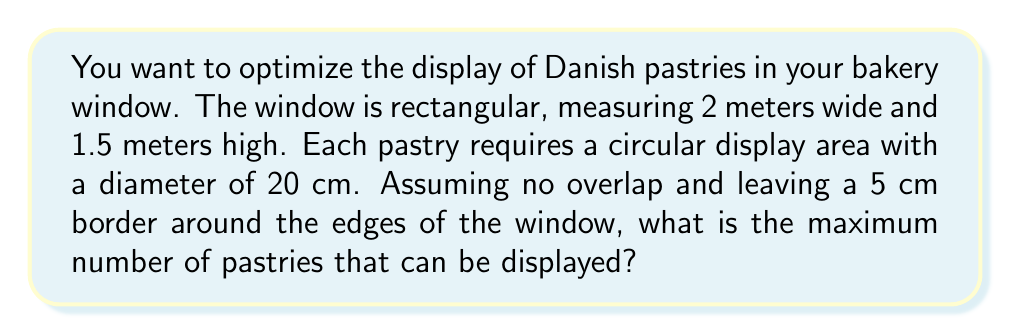Help me with this question. Let's approach this step-by-step:

1) First, calculate the usable area of the window:
   - Width: $2 \text{ m} - (2 \times 0.05 \text{ m}) = 1.9 \text{ m} = 190 \text{ cm}$
   - Height: $1.5 \text{ m} - (2 \times 0.05 \text{ m}) = 1.4 \text{ m} = 140 \text{ cm}$

2) The area needed for each pastry is a circle with diameter 20 cm:
   - Radius = $10 \text{ cm}$
   - Area per pastry = $\pi r^2 = \pi (10 \text{ cm})^2 = 100\pi \text{ cm}^2$

3) To maximize the number of pastries, we need to consider the most efficient packing of circles. The best packing density for circles is achieved with a hexagonal arrangement, which has a packing density of:

   $$\frac{\pi}{2\sqrt{3}} \approx 0.9069$$

4) Calculate the total usable area:
   $190 \text{ cm} \times 140 \text{ cm} = 26,600 \text{ cm}^2$

5) The theoretical maximum number of pastries (n) can be calculated as:

   $$n = \frac{\text{Total Area} \times \text{Packing Density}}{\text{Area per Pastry}}$$

   $$n = \frac{26,600 \text{ cm}^2 \times 0.9069}{100\pi \text{ cm}^2} \approx 76.77$$

6) Since we can't display partial pastries, we round down to the nearest whole number.

Therefore, the maximum number of pastries that can be displayed is 76.
Answer: 76 pastries 